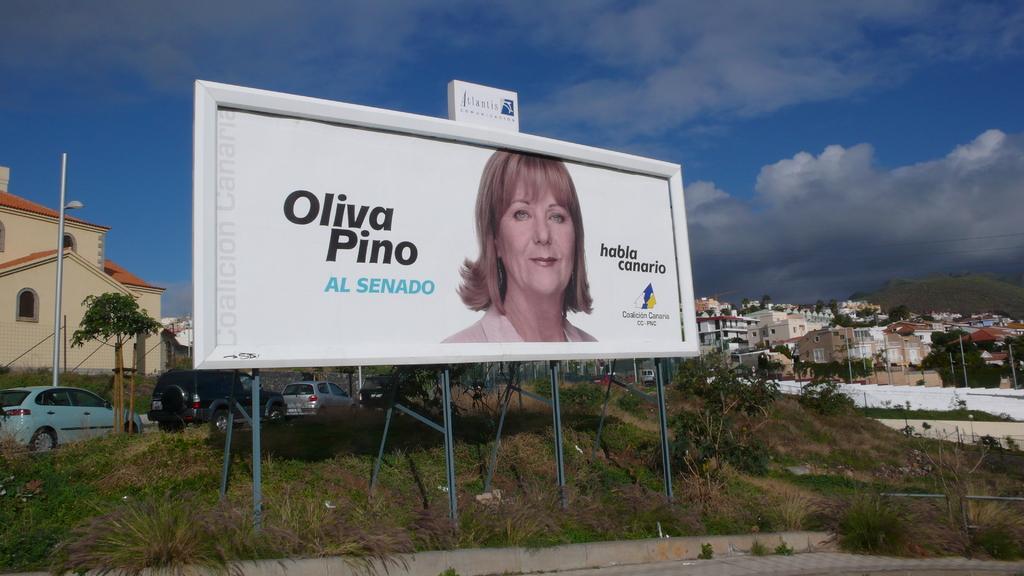Who is pictured on the billboard?
Offer a terse response. Oliva pino. What words are in light blue on the billboard?
Your response must be concise. Al senado. 